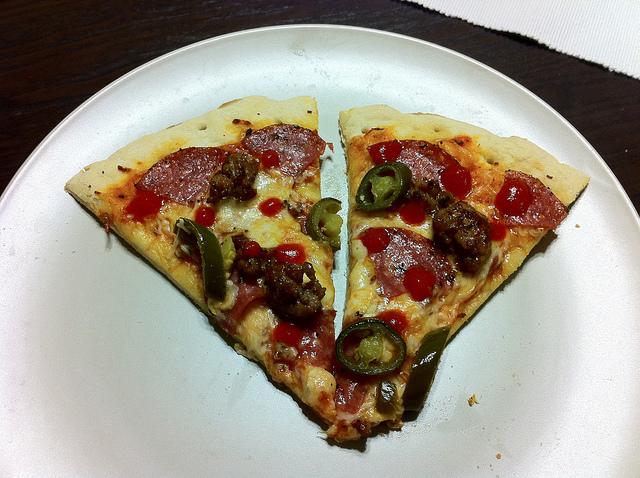What are the green things on the pizza?
Answer briefly. Jalapenos. Is this meal healthy?
Short answer required. No. How many slices of the pizza have already been eaten?
Give a very brief answer. 6. 